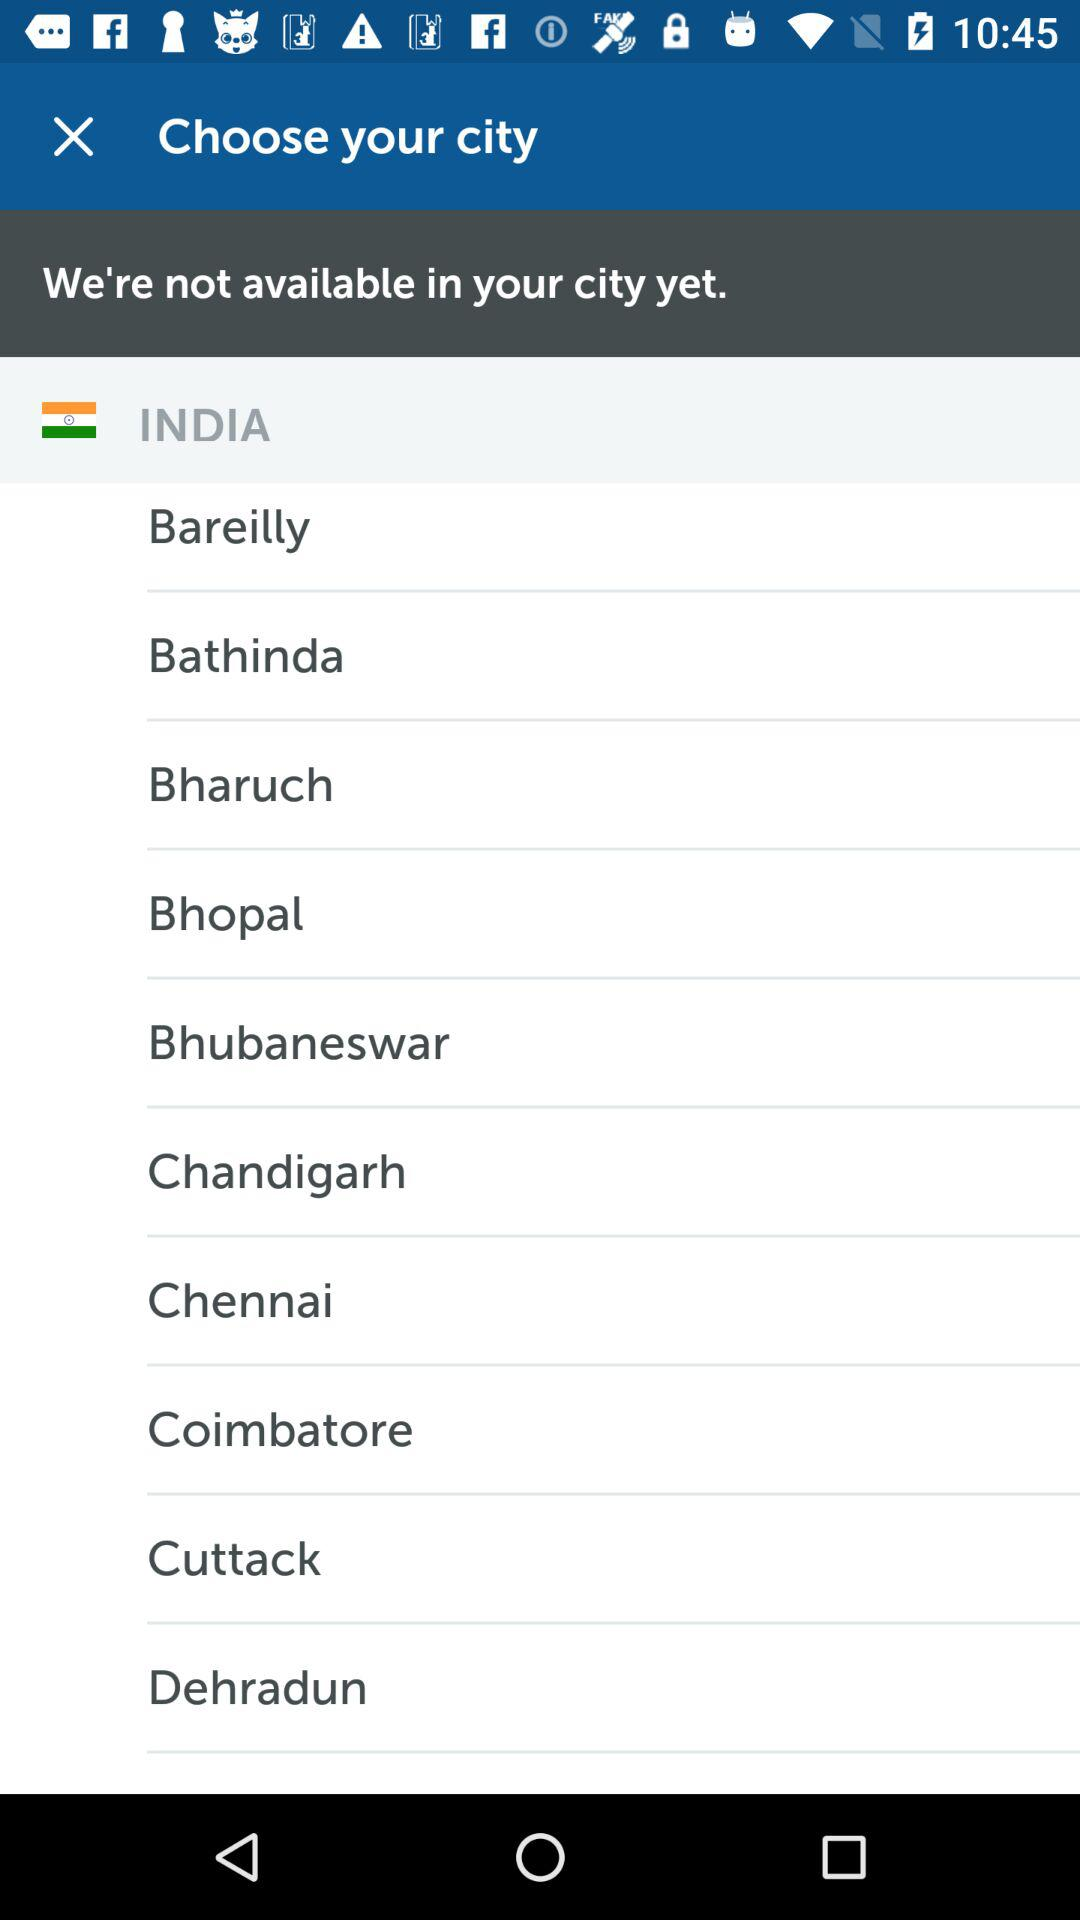What is the selected country? The selected country is India. 